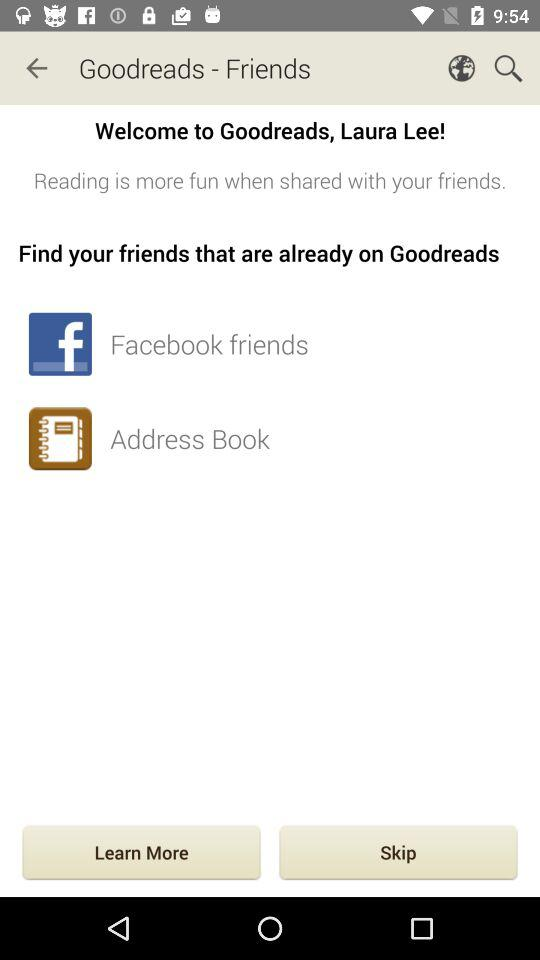Where can we find friends who are already on "Goodreads"? You can find friends on "Facebook" and "Address Book". 